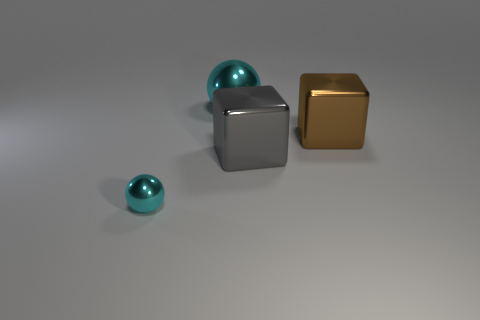What shape is the large metallic thing that is the same color as the tiny sphere?
Give a very brief answer. Sphere. How many other things are the same size as the brown thing?
Provide a short and direct response. 2. There is a thing that is left of the large cyan metal object; is its shape the same as the big brown metal thing?
Offer a terse response. No. Is the number of objects right of the big brown shiny cube greater than the number of big metallic cubes?
Give a very brief answer. No. The large object that is behind the big gray thing and on the left side of the brown thing is made of what material?
Ensure brevity in your answer.  Metal. Is there any other thing that has the same shape as the tiny cyan shiny object?
Provide a short and direct response. Yes. How many metal objects are both left of the big gray metallic block and on the right side of the small cyan object?
Provide a succinct answer. 1. What material is the tiny thing?
Make the answer very short. Metal. Is the number of big gray cubes behind the gray shiny cube the same as the number of big metal spheres?
Make the answer very short. No. How many big brown objects have the same shape as the tiny cyan thing?
Your response must be concise. 0. 